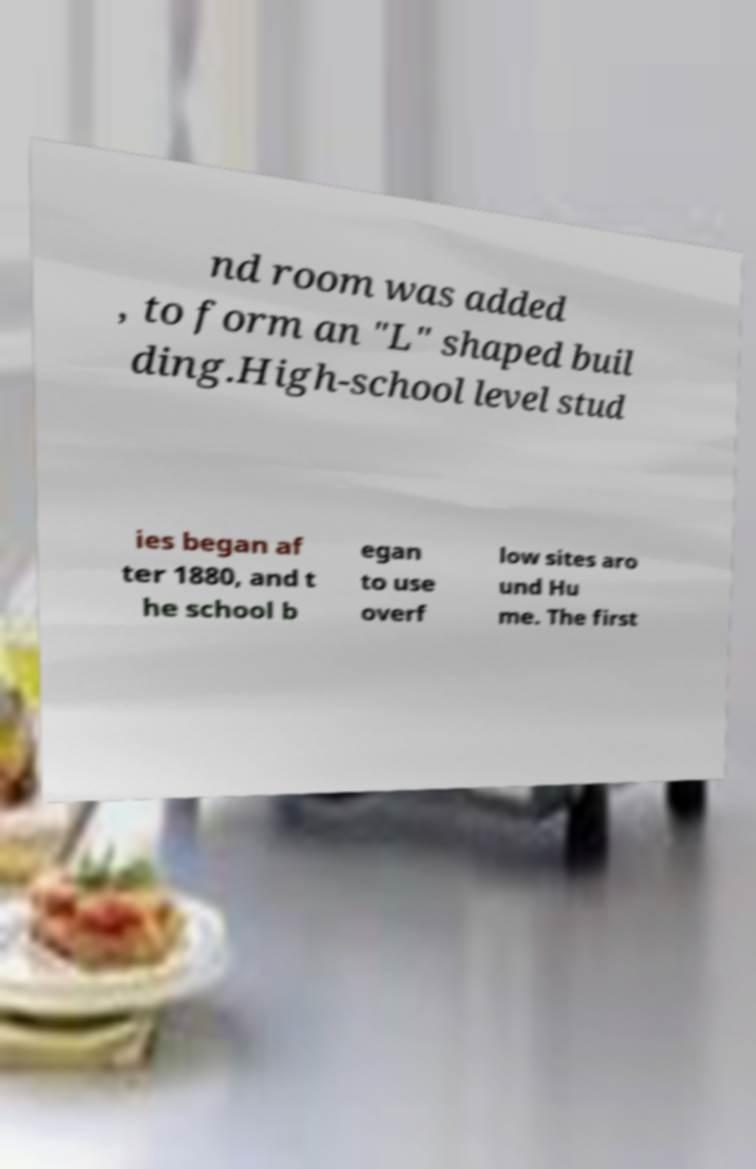Can you read and provide the text displayed in the image?This photo seems to have some interesting text. Can you extract and type it out for me? nd room was added , to form an "L" shaped buil ding.High-school level stud ies began af ter 1880, and t he school b egan to use overf low sites aro und Hu me. The first 